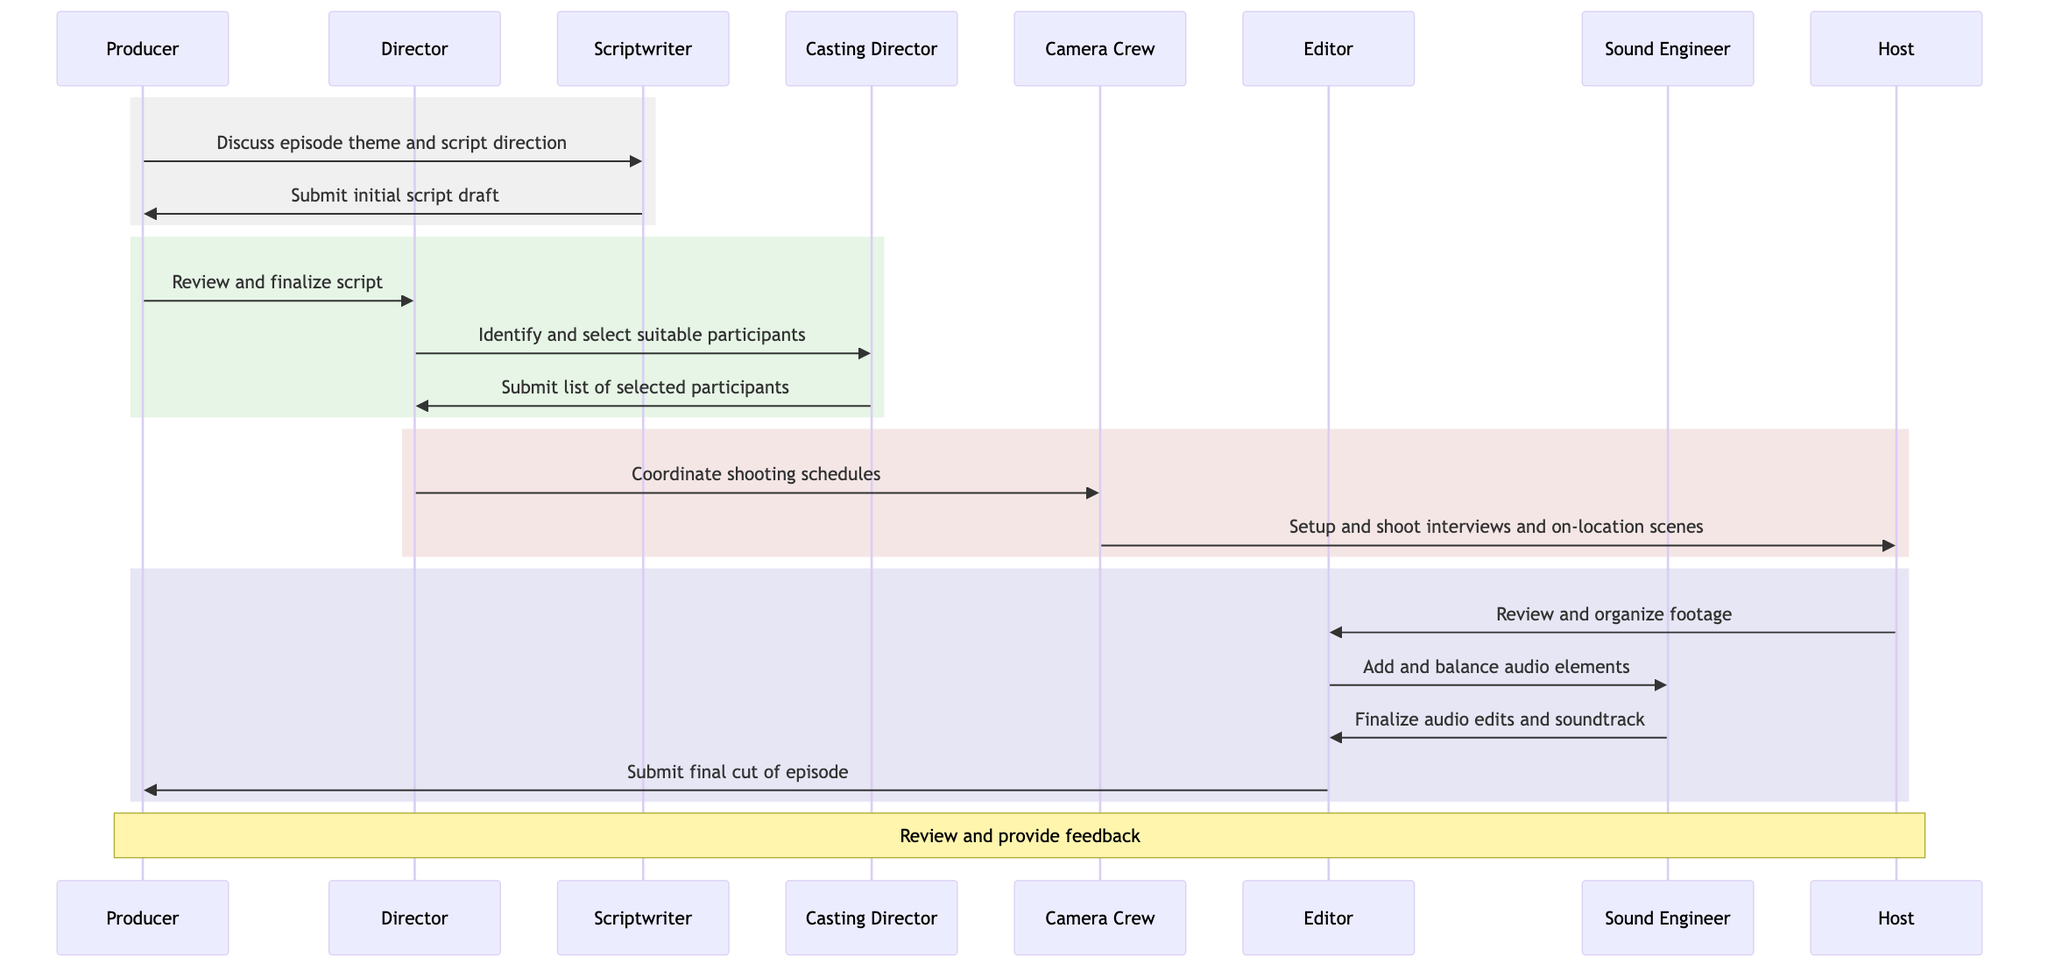What is the first message sent in the diagram? The first message in the diagram is sent from the Producer to the Scriptwriter discussing the episode theme and script direction.
Answer: Discuss episode theme and script direction How many main actors are involved in the production timeline? The diagram lists a total of eight actors involved: Producer, Director, Scriptwriter, Casting Director, Camera Crew, Editor, Sound Engineer, and Host.
Answer: Eight Who submits the final cut of the episode? The Editor submits the final cut of the episode to the Producer as the last step in the sequence.
Answer: Editor What is the last action taken by the Producer in the timeline? The last action taken by the Producer is to review and provide feedback on the completed episode after the final cut is submitted by the Editor.
Answer: Review and provide feedback Which actor coordinates shooting schedules? The Director is responsible for coordinating the shooting schedules with the Camera Crew in the timeline.
Answer: Director What happens after the host reviews and organizes the footage? After reviewing and organizing the footage, the Host sends it to the Editor, who then adds and balances the audio elements with assistance from the Sound Engineer.
Answer: Add and balance audio elements What is the relationship between the Casting Director and the Director? The Casting Director is responsible for identifying and selecting suitable participants based on the direction provided by the Director.
Answer: Identify and select suitable participants Which step involves the Sound Engineer? The Sound Engineer is involved in the step where they finalize audio edits and the soundtrack after the Editor adds and balances audio elements.
Answer: Finalize audio edits and soundtrack What is the primary focus of the first rectangle in the diagram? The primary focus of the first rectangle is the discussion between the Producer and Scriptwriter regarding the episode theme and script direction, leading to the submission of the initial script draft.
Answer: Discuss episode theme and script direction 